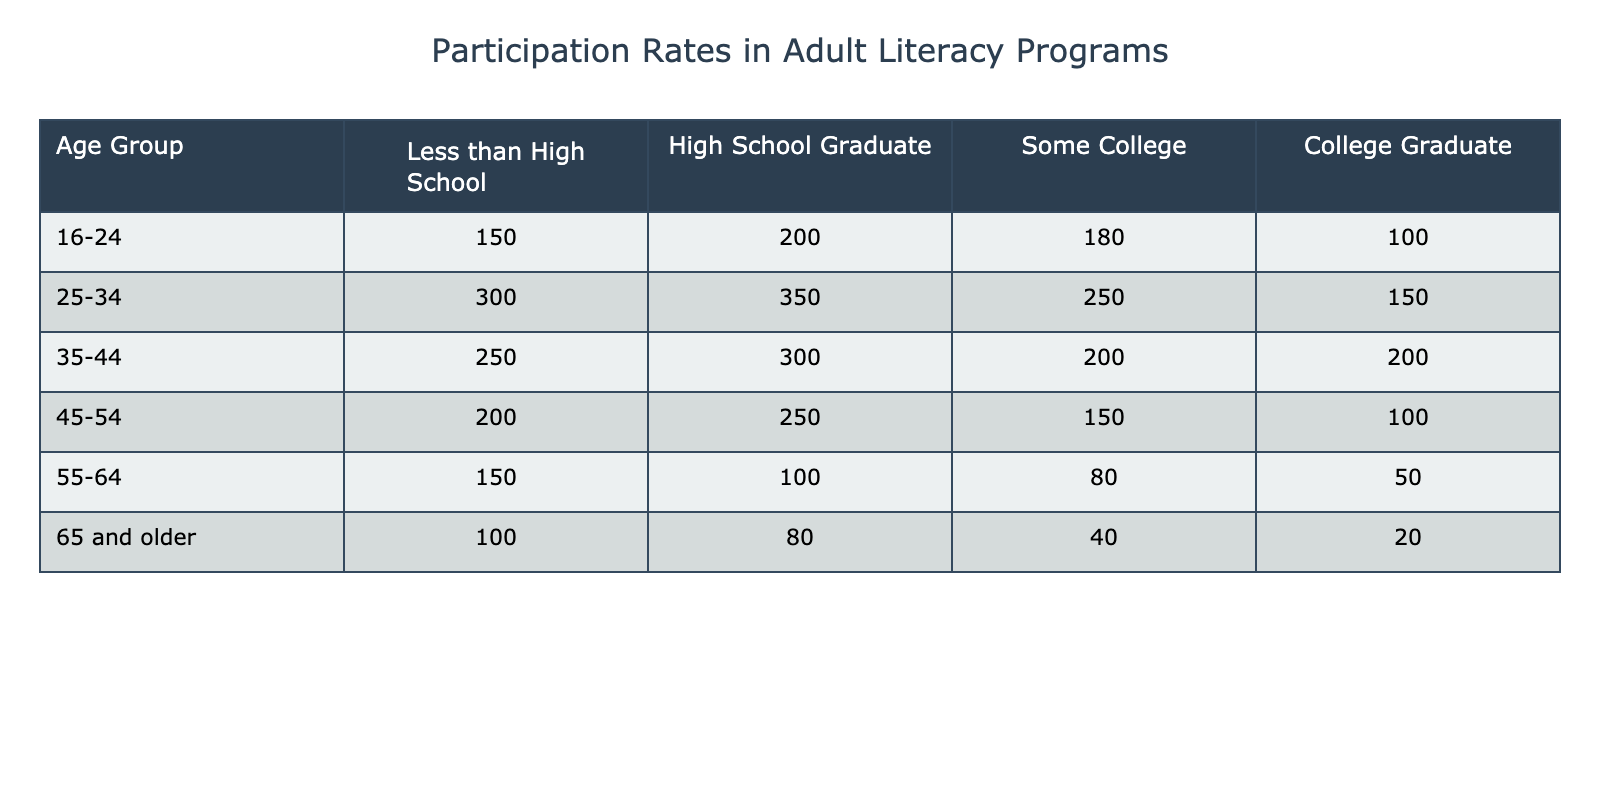What is the participation rate for the age group 25-34 who are High School Graduates? The participation rate for the age group 25-34 who are High School Graduates is listed directly in the table under the corresponding column. According to the table, it shows the value of 350.
Answer: 350 Which age group has the highest participation rate for those with some college education? By examining the column for "Some College", the values for each age group are 180, 250, 200, 150, 80, and 40. The highest value among these is 250, which corresponds to the age group 25-34.
Answer: 25-34 Is it true that the participation rate for College Graduates over 65 is greater than that for High School Graduates? Looking at the participation rates for the two groups: the participation rate for College Graduates aged 65 and older is 20, while the rate for High School Graduates in the same age group is 80. Since 20 is not greater than 80, the statement is false.
Answer: No What is the total participation rate for all age groups with less than a high school education? To find the total participation rate for this group, we need to sum the values for each age group for "Less than High School": 150 + 300 + 250 + 200 + 150 + 100 = 1150.
Answer: 1150 How does the participation rate for College Graduates compare between the age groups 35-44 and 55-64? In the "College Graduate" column, the participation rate for age group 35-44 is 200, and for age group 55-64, it is 50. Since 200 is greater than 50, this indicates that more College Graduates participate in age group 35-44 than in age group 55-64.
Answer: 35-44 has a higher rate than 55-64 